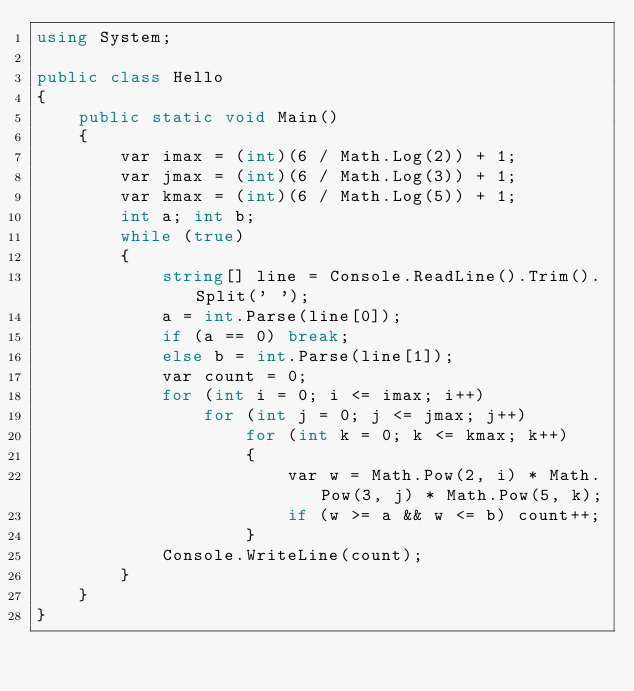<code> <loc_0><loc_0><loc_500><loc_500><_C#_>using System;

public class Hello
{
    public static void Main()
    {
        var imax = (int)(6 / Math.Log(2)) + 1;
        var jmax = (int)(6 / Math.Log(3)) + 1;
        var kmax = (int)(6 / Math.Log(5)) + 1;
        int a; int b;
        while (true)
        {
            string[] line = Console.ReadLine().Trim().Split(' ');
            a = int.Parse(line[0]);
            if (a == 0) break;
            else b = int.Parse(line[1]);
            var count = 0;
            for (int i = 0; i <= imax; i++)
                for (int j = 0; j <= jmax; j++)
                    for (int k = 0; k <= kmax; k++)
                    {
                        var w = Math.Pow(2, i) * Math.Pow(3, j) * Math.Pow(5, k);
                        if (w >= a && w <= b) count++;
                    }
            Console.WriteLine(count);
        }
    }
}

</code> 